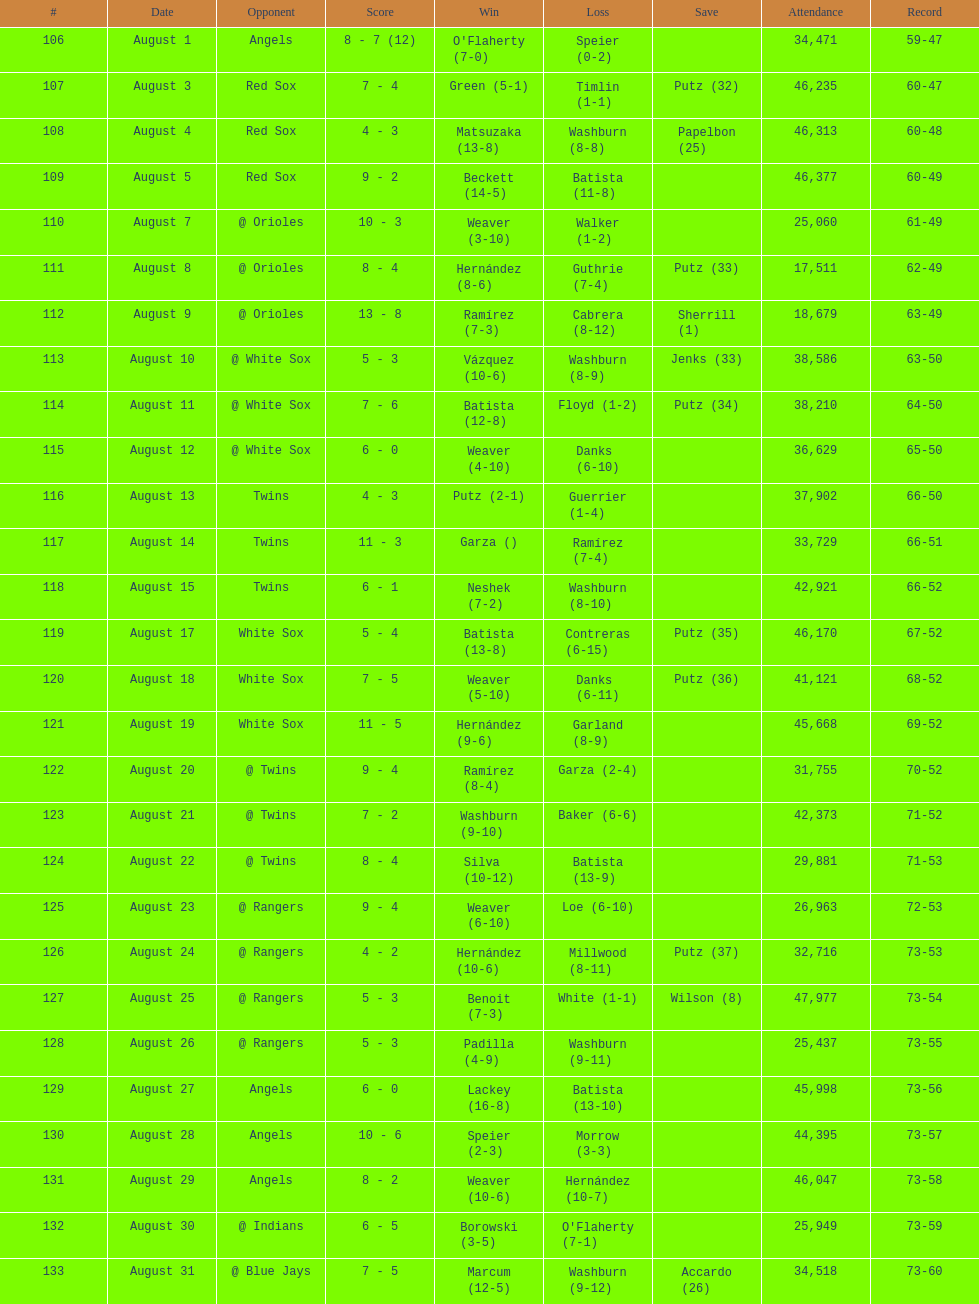What was the total number of losses in the stretch? 7. 